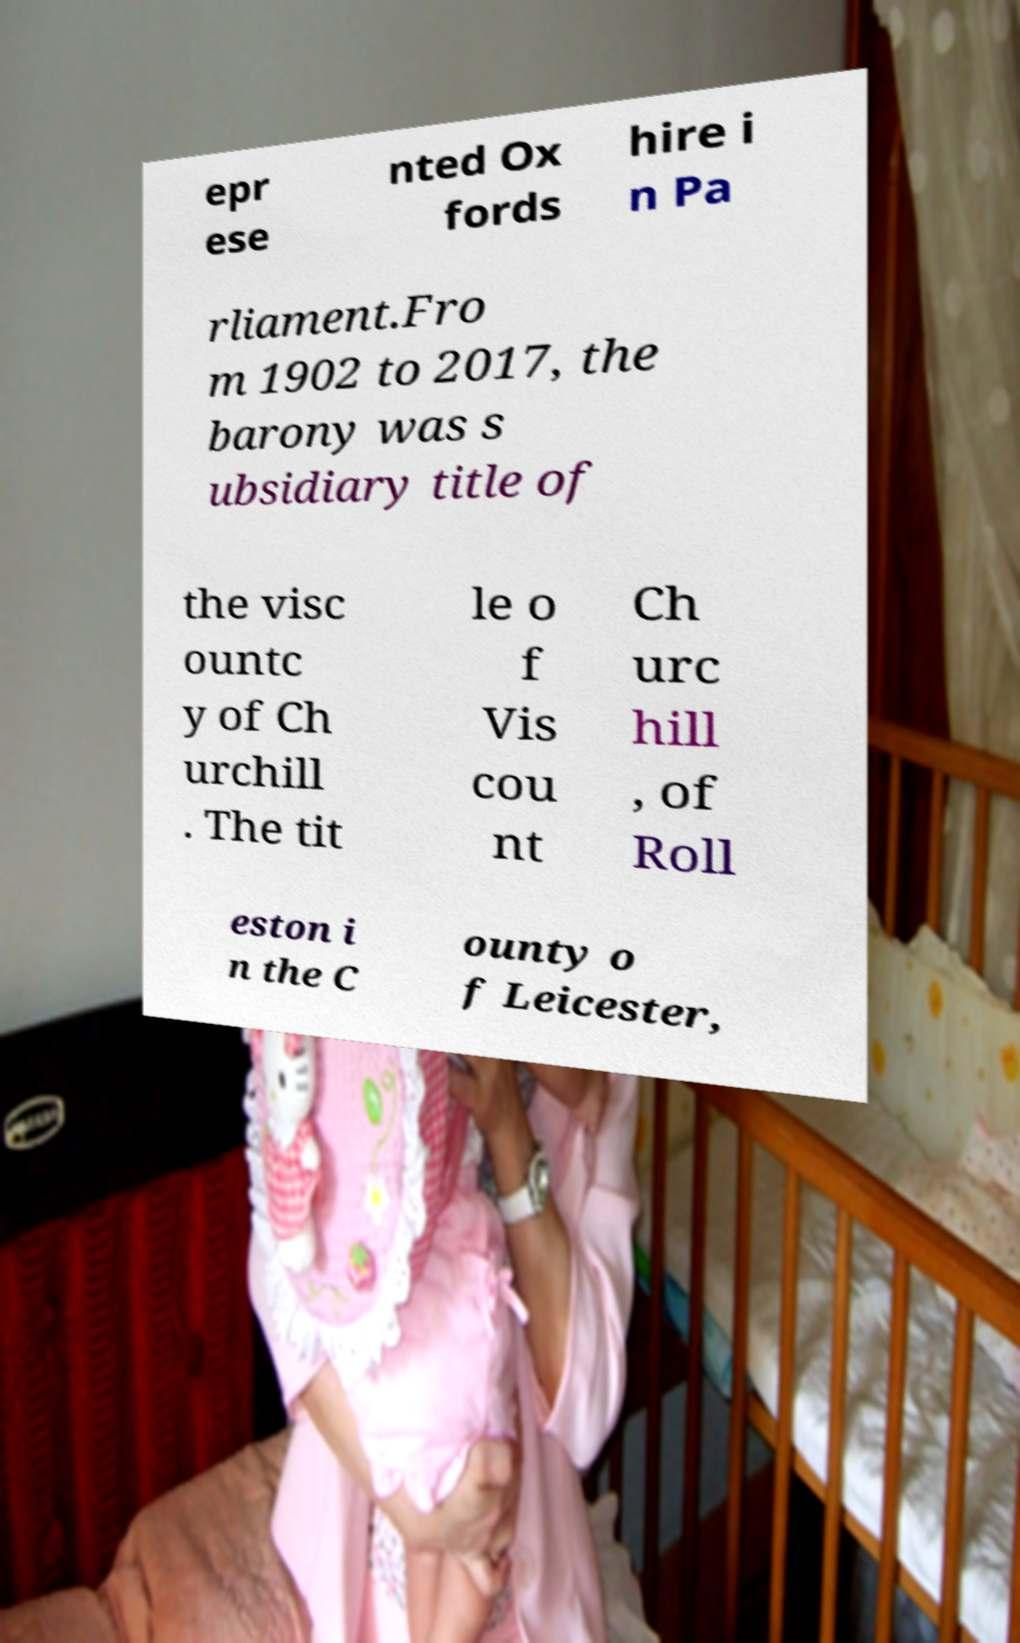Please read and relay the text visible in this image. What does it say? epr ese nted Ox fords hire i n Pa rliament.Fro m 1902 to 2017, the barony was s ubsidiary title of the visc ountc y of Ch urchill . The tit le o f Vis cou nt Ch urc hill , of Roll eston i n the C ounty o f Leicester, 